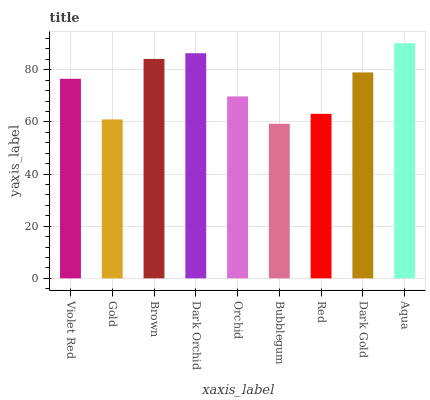Is Gold the minimum?
Answer yes or no. No. Is Gold the maximum?
Answer yes or no. No. Is Violet Red greater than Gold?
Answer yes or no. Yes. Is Gold less than Violet Red?
Answer yes or no. Yes. Is Gold greater than Violet Red?
Answer yes or no. No. Is Violet Red less than Gold?
Answer yes or no. No. Is Violet Red the high median?
Answer yes or no. Yes. Is Violet Red the low median?
Answer yes or no. Yes. Is Aqua the high median?
Answer yes or no. No. Is Red the low median?
Answer yes or no. No. 